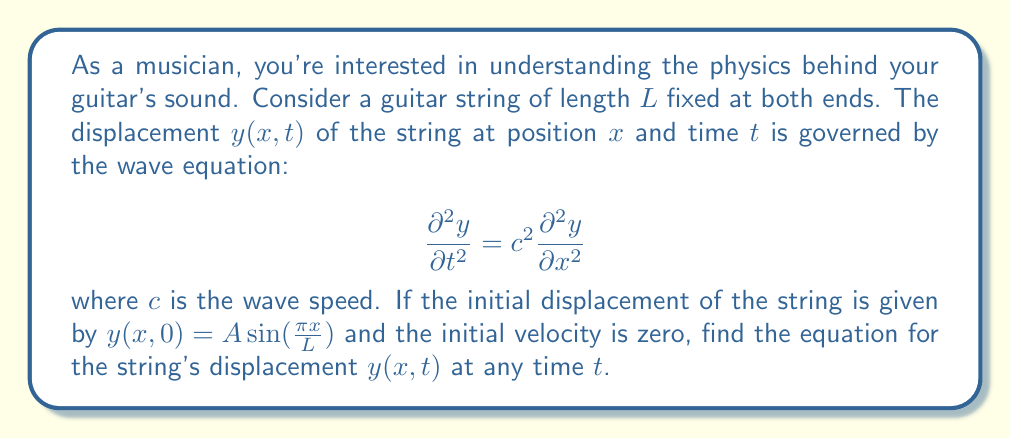Teach me how to tackle this problem. Let's solve this step-by-step:

1) The general solution to the wave equation for a string fixed at both ends is:

   $$y(x,t) = \sum_{n=1}^{\infty} (A_n \cos(\omega_n t) + B_n \sin(\omega_n t)) \sin(\frac{n\pi x}{L})$$

   where $\omega_n = \frac{n\pi c}{L}$

2) Given the initial conditions:
   - $y(x,0) = A \sin(\frac{\pi x}{L})$
   - $\frac{\partial y}{\partial t}(x,0) = 0$

3) Comparing the initial displacement with the general solution at $t=0$:

   $$A \sin(\frac{\pi x}{L}) = \sum_{n=1}^{\infty} A_n \sin(\frac{n\pi x}{L})$$

   This implies $A_1 = A$ and $A_n = 0$ for $n > 1$

4) The initial velocity condition gives:

   $$0 = \sum_{n=1}^{\infty} B_n \omega_n \sin(\frac{n\pi x}{L})$$

   This implies $B_n = 0$ for all $n$

5) Therefore, our solution reduces to:

   $$y(x,t) = A \cos(\omega_1 t) \sin(\frac{\pi x}{L})$$

6) Substituting $\omega_1 = \frac{\pi c}{L}$, we get:

   $$y(x,t) = A \cos(\frac{\pi c t}{L}) \sin(\frac{\pi x}{L})$$

This equation represents a standing wave, which is characteristic of the resonance of a guitar string.
Answer: $y(x,t) = A \cos(\frac{\pi c t}{L}) \sin(\frac{\pi x}{L})$ 